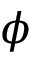Convert formula to latex. <formula><loc_0><loc_0><loc_500><loc_500>\phi</formula> 